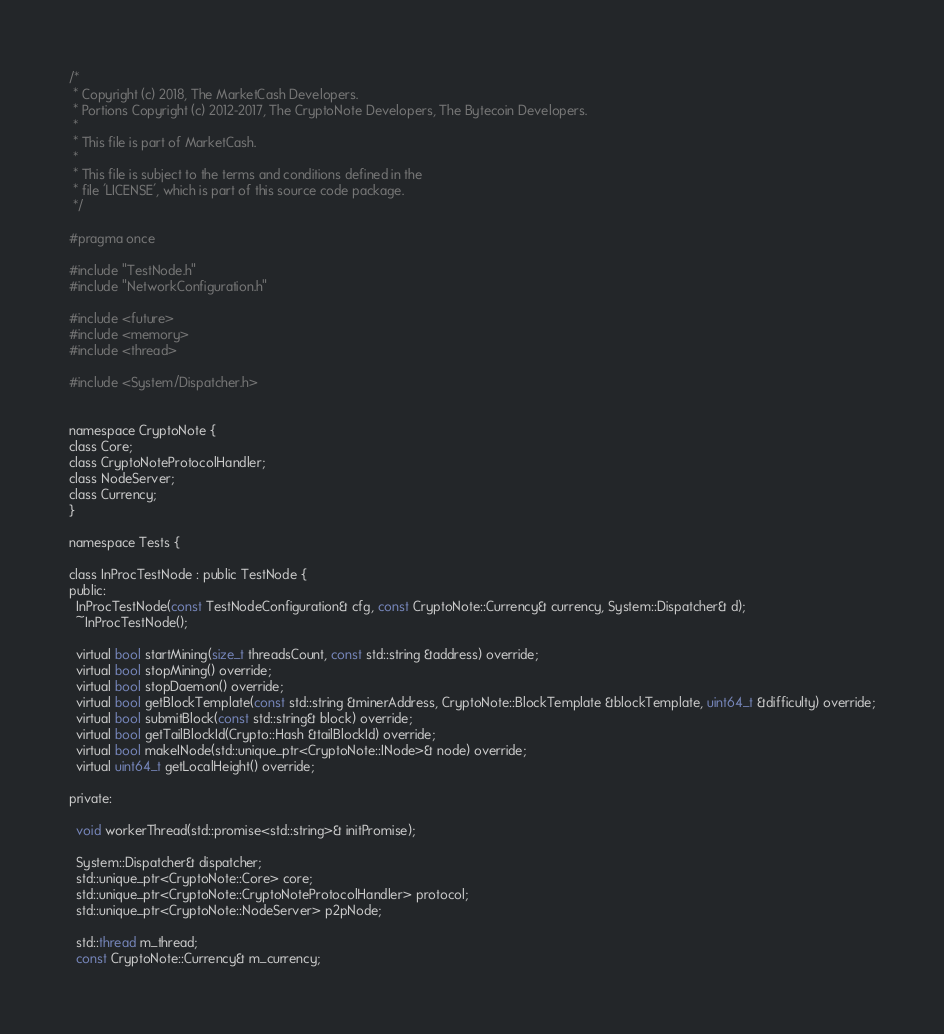Convert code to text. <code><loc_0><loc_0><loc_500><loc_500><_C_>/*
 * Copyright (c) 2018, The MarketCash Developers.
 * Portions Copyright (c) 2012-2017, The CryptoNote Developers, The Bytecoin Developers.
 *
 * This file is part of MarketCash.
 *
 * This file is subject to the terms and conditions defined in the
 * file 'LICENSE', which is part of this source code package.
 */

#pragma once

#include "TestNode.h"
#include "NetworkConfiguration.h"

#include <future>
#include <memory>
#include <thread>

#include <System/Dispatcher.h>


namespace CryptoNote {
class Core;
class CryptoNoteProtocolHandler;
class NodeServer;
class Currency;
}

namespace Tests {

class InProcTestNode : public TestNode {
public:
  InProcTestNode(const TestNodeConfiguration& cfg, const CryptoNote::Currency& currency, System::Dispatcher& d);
  ~InProcTestNode();

  virtual bool startMining(size_t threadsCount, const std::string &address) override;
  virtual bool stopMining() override;
  virtual bool stopDaemon() override;
  virtual bool getBlockTemplate(const std::string &minerAddress, CryptoNote::BlockTemplate &blockTemplate, uint64_t &difficulty) override;
  virtual bool submitBlock(const std::string& block) override;
  virtual bool getTailBlockId(Crypto::Hash &tailBlockId) override;
  virtual bool makeINode(std::unique_ptr<CryptoNote::INode>& node) override;
  virtual uint64_t getLocalHeight() override;

private:

  void workerThread(std::promise<std::string>& initPromise);

  System::Dispatcher& dispatcher;
  std::unique_ptr<CryptoNote::Core> core;
  std::unique_ptr<CryptoNote::CryptoNoteProtocolHandler> protocol;
  std::unique_ptr<CryptoNote::NodeServer> p2pNode;

  std::thread m_thread;
  const CryptoNote::Currency& m_currency;</code> 